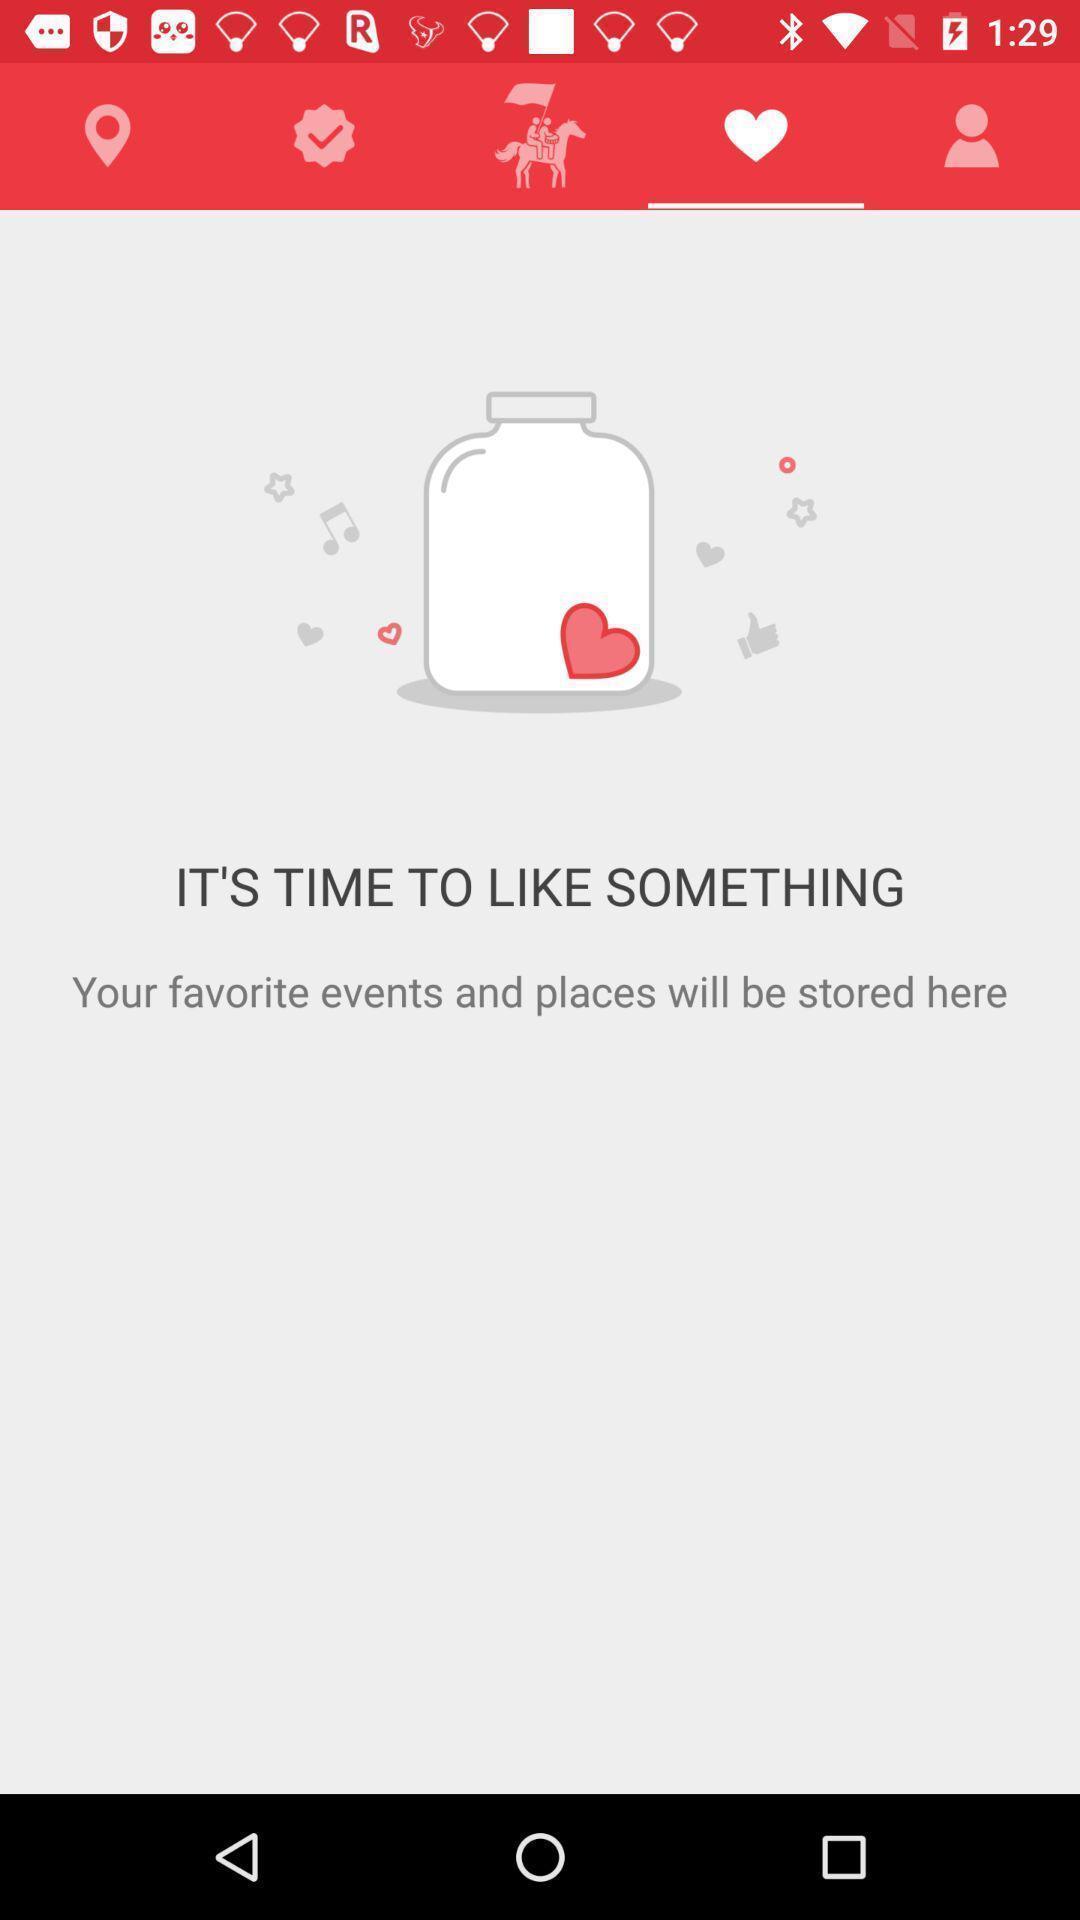Tell me about the visual elements in this screen capture. Screen displaying multiple icons and content in favorites page. 